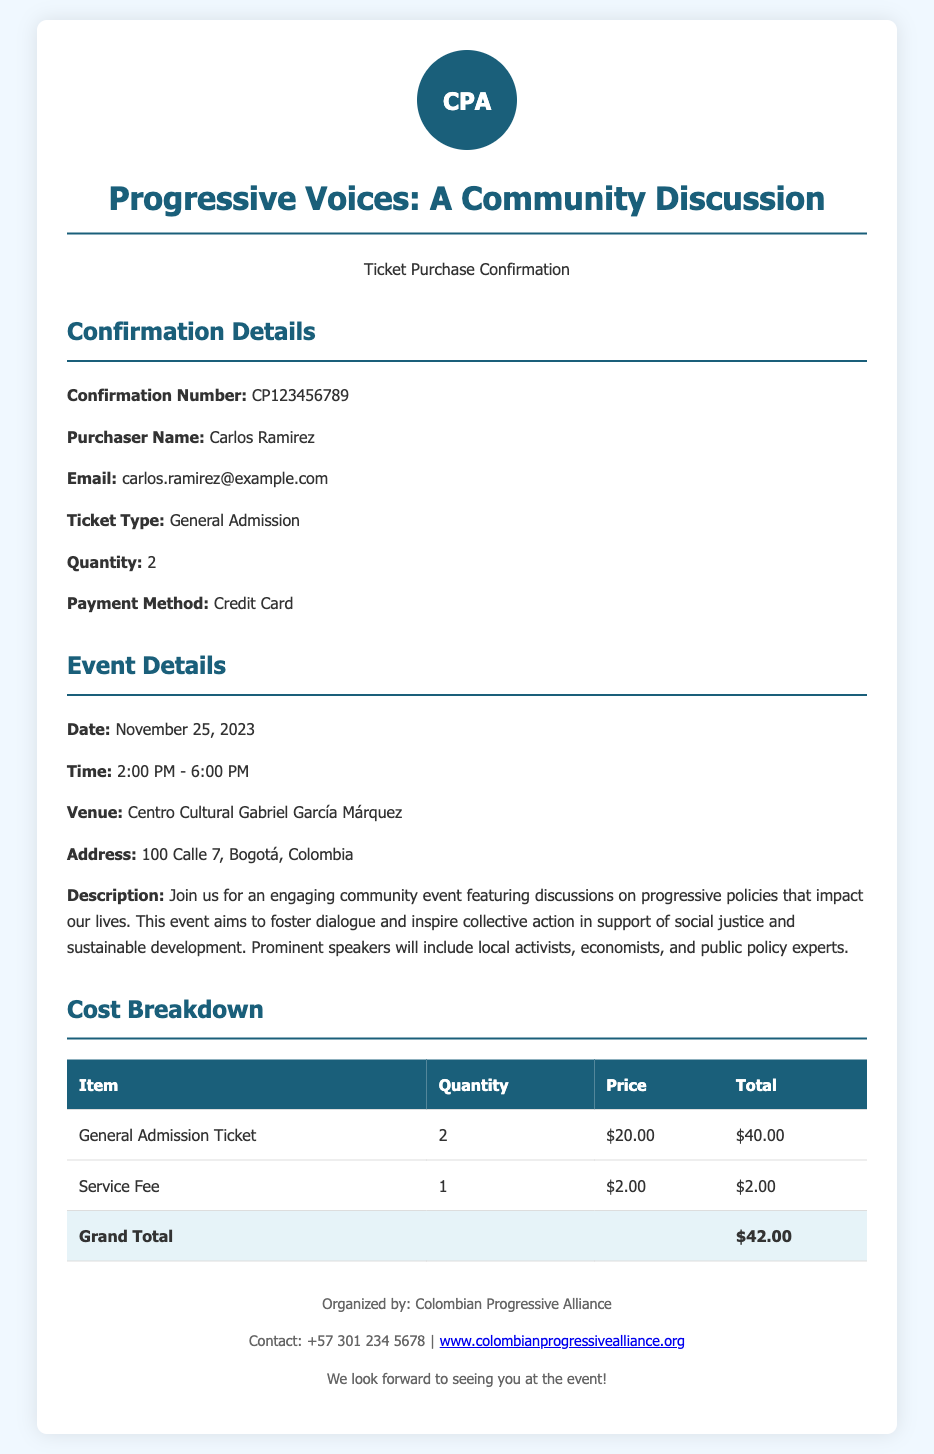What is the confirmation number? The confirmation number is explicitly listed in the document under "Confirmation Details."
Answer: CP123456789 Who is the purchaser? The purchaser's name is provided in the confirmation section of the document.
Answer: Carlos Ramirez How many tickets were purchased? The quantity of tickets is specified in the confirmation details.
Answer: 2 What is the date of the event? The date of the event is stated in the event details section.
Answer: November 25, 2023 What is the grand total? The grand total is calculated and shown in the cost breakdown table.
Answer: $42.00 What time does the event start? The start time is clearly mentioned in the event details.
Answer: 2:00 PM Where is the event taking place? The venue address is provided in the event details section of the document.
Answer: Centro Cultural Gabriel García Márquez What type of ticket was purchased? The type of ticket is stated in the confirmation details of the document.
Answer: General Admission 